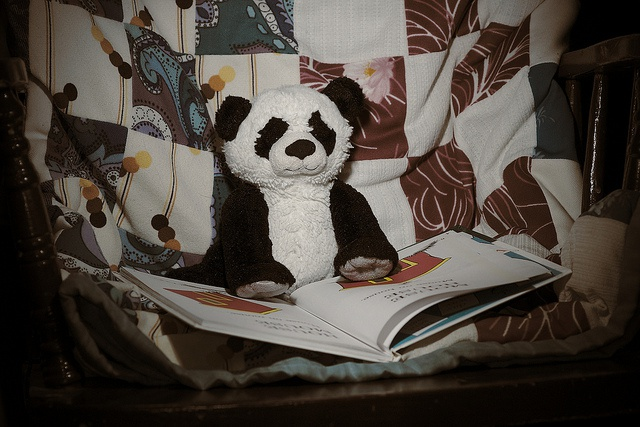Describe the objects in this image and their specific colors. I can see chair in black, darkgray, gray, and maroon tones, couch in black, darkgray, gray, and maroon tones, bear in black, darkgray, gray, and lightgray tones, teddy bear in black, darkgray, lightgray, and gray tones, and book in black, darkgray, gray, and maroon tones in this image. 